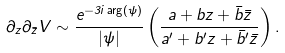<formula> <loc_0><loc_0><loc_500><loc_500>\partial _ { z } \partial _ { \bar { z } } V \sim \frac { e ^ { - 3 i \arg ( \psi ) } } { | \psi | } \left ( \frac { a + b z + { \bar { b } } { \bar { z } } } { a ^ { \prime } + b ^ { \prime } z + { \bar { b } } ^ { \prime } { \bar { z } } } \right ) .</formula> 